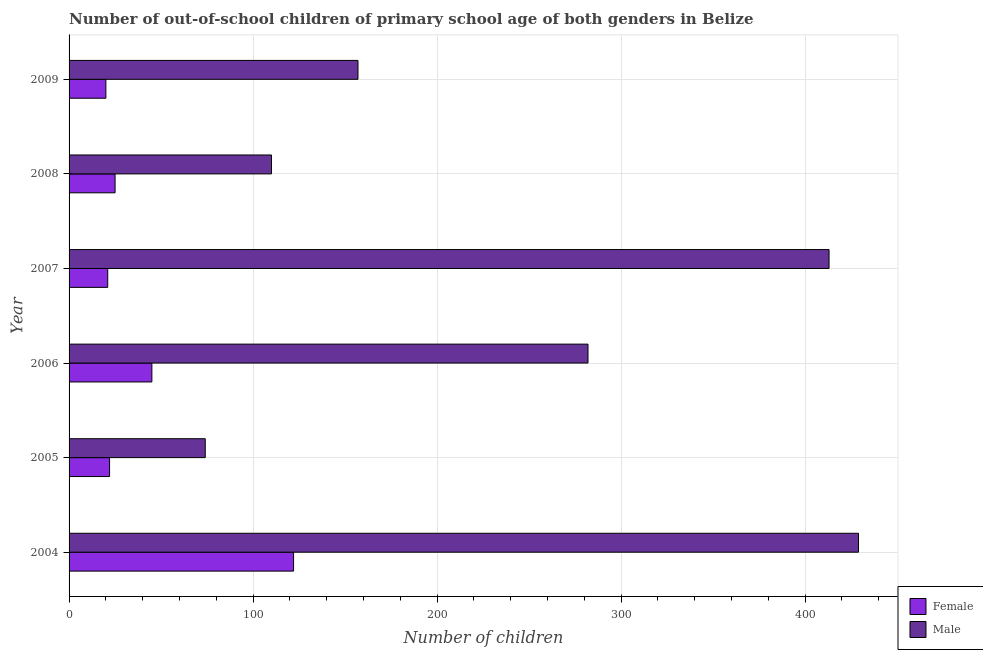How many bars are there on the 3rd tick from the bottom?
Keep it short and to the point. 2. What is the label of the 3rd group of bars from the top?
Provide a succinct answer. 2007. What is the number of male out-of-school students in 2007?
Make the answer very short. 413. Across all years, what is the maximum number of male out-of-school students?
Your response must be concise. 429. Across all years, what is the minimum number of male out-of-school students?
Provide a short and direct response. 74. What is the total number of female out-of-school students in the graph?
Offer a terse response. 255. What is the difference between the number of female out-of-school students in 2004 and that in 2005?
Your response must be concise. 100. What is the difference between the number of male out-of-school students in 2009 and the number of female out-of-school students in 2007?
Your answer should be compact. 136. What is the average number of female out-of-school students per year?
Your answer should be very brief. 42.5. In the year 2005, what is the difference between the number of female out-of-school students and number of male out-of-school students?
Offer a very short reply. -52. What is the ratio of the number of male out-of-school students in 2008 to that in 2009?
Offer a terse response. 0.7. Is the number of male out-of-school students in 2006 less than that in 2009?
Make the answer very short. No. Is the difference between the number of male out-of-school students in 2007 and 2008 greater than the difference between the number of female out-of-school students in 2007 and 2008?
Your answer should be very brief. Yes. What is the difference between the highest and the second highest number of female out-of-school students?
Offer a terse response. 77. What is the difference between the highest and the lowest number of male out-of-school students?
Ensure brevity in your answer.  355. Is the sum of the number of female out-of-school students in 2006 and 2009 greater than the maximum number of male out-of-school students across all years?
Your answer should be compact. No. Are all the bars in the graph horizontal?
Keep it short and to the point. Yes. How many years are there in the graph?
Offer a terse response. 6. Does the graph contain any zero values?
Your answer should be compact. No. Does the graph contain grids?
Give a very brief answer. Yes. How many legend labels are there?
Make the answer very short. 2. What is the title of the graph?
Keep it short and to the point. Number of out-of-school children of primary school age of both genders in Belize. What is the label or title of the X-axis?
Give a very brief answer. Number of children. What is the label or title of the Y-axis?
Provide a succinct answer. Year. What is the Number of children of Female in 2004?
Give a very brief answer. 122. What is the Number of children of Male in 2004?
Offer a terse response. 429. What is the Number of children of Male in 2006?
Offer a very short reply. 282. What is the Number of children in Male in 2007?
Offer a very short reply. 413. What is the Number of children of Female in 2008?
Your response must be concise. 25. What is the Number of children of Male in 2008?
Your answer should be compact. 110. What is the Number of children in Male in 2009?
Offer a very short reply. 157. Across all years, what is the maximum Number of children in Female?
Offer a very short reply. 122. Across all years, what is the maximum Number of children in Male?
Your answer should be very brief. 429. What is the total Number of children in Female in the graph?
Your answer should be compact. 255. What is the total Number of children of Male in the graph?
Make the answer very short. 1465. What is the difference between the Number of children of Female in 2004 and that in 2005?
Offer a very short reply. 100. What is the difference between the Number of children in Male in 2004 and that in 2005?
Provide a short and direct response. 355. What is the difference between the Number of children of Male in 2004 and that in 2006?
Your response must be concise. 147. What is the difference between the Number of children in Female in 2004 and that in 2007?
Provide a short and direct response. 101. What is the difference between the Number of children in Female in 2004 and that in 2008?
Offer a terse response. 97. What is the difference between the Number of children of Male in 2004 and that in 2008?
Offer a very short reply. 319. What is the difference between the Number of children of Female in 2004 and that in 2009?
Offer a very short reply. 102. What is the difference between the Number of children in Male in 2004 and that in 2009?
Provide a succinct answer. 272. What is the difference between the Number of children in Male in 2005 and that in 2006?
Your response must be concise. -208. What is the difference between the Number of children of Female in 2005 and that in 2007?
Your response must be concise. 1. What is the difference between the Number of children of Male in 2005 and that in 2007?
Provide a short and direct response. -339. What is the difference between the Number of children of Female in 2005 and that in 2008?
Give a very brief answer. -3. What is the difference between the Number of children in Male in 2005 and that in 2008?
Offer a very short reply. -36. What is the difference between the Number of children in Male in 2005 and that in 2009?
Your answer should be very brief. -83. What is the difference between the Number of children of Female in 2006 and that in 2007?
Ensure brevity in your answer.  24. What is the difference between the Number of children in Male in 2006 and that in 2007?
Provide a short and direct response. -131. What is the difference between the Number of children in Female in 2006 and that in 2008?
Your answer should be compact. 20. What is the difference between the Number of children of Male in 2006 and that in 2008?
Provide a succinct answer. 172. What is the difference between the Number of children in Female in 2006 and that in 2009?
Your answer should be very brief. 25. What is the difference between the Number of children of Male in 2006 and that in 2009?
Ensure brevity in your answer.  125. What is the difference between the Number of children of Male in 2007 and that in 2008?
Your answer should be compact. 303. What is the difference between the Number of children in Male in 2007 and that in 2009?
Your response must be concise. 256. What is the difference between the Number of children of Female in 2008 and that in 2009?
Provide a succinct answer. 5. What is the difference between the Number of children in Male in 2008 and that in 2009?
Make the answer very short. -47. What is the difference between the Number of children in Female in 2004 and the Number of children in Male in 2006?
Make the answer very short. -160. What is the difference between the Number of children of Female in 2004 and the Number of children of Male in 2007?
Make the answer very short. -291. What is the difference between the Number of children of Female in 2004 and the Number of children of Male in 2009?
Your response must be concise. -35. What is the difference between the Number of children in Female in 2005 and the Number of children in Male in 2006?
Your response must be concise. -260. What is the difference between the Number of children in Female in 2005 and the Number of children in Male in 2007?
Make the answer very short. -391. What is the difference between the Number of children of Female in 2005 and the Number of children of Male in 2008?
Provide a short and direct response. -88. What is the difference between the Number of children of Female in 2005 and the Number of children of Male in 2009?
Offer a terse response. -135. What is the difference between the Number of children of Female in 2006 and the Number of children of Male in 2007?
Make the answer very short. -368. What is the difference between the Number of children in Female in 2006 and the Number of children in Male in 2008?
Make the answer very short. -65. What is the difference between the Number of children of Female in 2006 and the Number of children of Male in 2009?
Your answer should be compact. -112. What is the difference between the Number of children of Female in 2007 and the Number of children of Male in 2008?
Offer a terse response. -89. What is the difference between the Number of children of Female in 2007 and the Number of children of Male in 2009?
Make the answer very short. -136. What is the difference between the Number of children in Female in 2008 and the Number of children in Male in 2009?
Provide a short and direct response. -132. What is the average Number of children in Female per year?
Provide a succinct answer. 42.5. What is the average Number of children in Male per year?
Your response must be concise. 244.17. In the year 2004, what is the difference between the Number of children in Female and Number of children in Male?
Keep it short and to the point. -307. In the year 2005, what is the difference between the Number of children in Female and Number of children in Male?
Give a very brief answer. -52. In the year 2006, what is the difference between the Number of children in Female and Number of children in Male?
Make the answer very short. -237. In the year 2007, what is the difference between the Number of children in Female and Number of children in Male?
Offer a terse response. -392. In the year 2008, what is the difference between the Number of children in Female and Number of children in Male?
Ensure brevity in your answer.  -85. In the year 2009, what is the difference between the Number of children of Female and Number of children of Male?
Your answer should be very brief. -137. What is the ratio of the Number of children of Female in 2004 to that in 2005?
Your answer should be compact. 5.55. What is the ratio of the Number of children of Male in 2004 to that in 2005?
Provide a short and direct response. 5.8. What is the ratio of the Number of children of Female in 2004 to that in 2006?
Offer a very short reply. 2.71. What is the ratio of the Number of children of Male in 2004 to that in 2006?
Your answer should be compact. 1.52. What is the ratio of the Number of children in Female in 2004 to that in 2007?
Offer a terse response. 5.81. What is the ratio of the Number of children of Male in 2004 to that in 2007?
Offer a very short reply. 1.04. What is the ratio of the Number of children in Female in 2004 to that in 2008?
Offer a very short reply. 4.88. What is the ratio of the Number of children in Male in 2004 to that in 2008?
Your answer should be compact. 3.9. What is the ratio of the Number of children of Female in 2004 to that in 2009?
Your response must be concise. 6.1. What is the ratio of the Number of children in Male in 2004 to that in 2009?
Provide a short and direct response. 2.73. What is the ratio of the Number of children in Female in 2005 to that in 2006?
Provide a succinct answer. 0.49. What is the ratio of the Number of children of Male in 2005 to that in 2006?
Keep it short and to the point. 0.26. What is the ratio of the Number of children in Female in 2005 to that in 2007?
Keep it short and to the point. 1.05. What is the ratio of the Number of children in Male in 2005 to that in 2007?
Your answer should be very brief. 0.18. What is the ratio of the Number of children in Female in 2005 to that in 2008?
Ensure brevity in your answer.  0.88. What is the ratio of the Number of children in Male in 2005 to that in 2008?
Your answer should be very brief. 0.67. What is the ratio of the Number of children in Female in 2005 to that in 2009?
Your response must be concise. 1.1. What is the ratio of the Number of children in Male in 2005 to that in 2009?
Your answer should be very brief. 0.47. What is the ratio of the Number of children in Female in 2006 to that in 2007?
Provide a short and direct response. 2.14. What is the ratio of the Number of children of Male in 2006 to that in 2007?
Your response must be concise. 0.68. What is the ratio of the Number of children in Female in 2006 to that in 2008?
Offer a terse response. 1.8. What is the ratio of the Number of children of Male in 2006 to that in 2008?
Provide a succinct answer. 2.56. What is the ratio of the Number of children of Female in 2006 to that in 2009?
Give a very brief answer. 2.25. What is the ratio of the Number of children in Male in 2006 to that in 2009?
Ensure brevity in your answer.  1.8. What is the ratio of the Number of children in Female in 2007 to that in 2008?
Your response must be concise. 0.84. What is the ratio of the Number of children in Male in 2007 to that in 2008?
Ensure brevity in your answer.  3.75. What is the ratio of the Number of children of Male in 2007 to that in 2009?
Offer a very short reply. 2.63. What is the ratio of the Number of children in Male in 2008 to that in 2009?
Ensure brevity in your answer.  0.7. What is the difference between the highest and the second highest Number of children in Female?
Make the answer very short. 77. What is the difference between the highest and the second highest Number of children in Male?
Your answer should be very brief. 16. What is the difference between the highest and the lowest Number of children of Female?
Provide a succinct answer. 102. What is the difference between the highest and the lowest Number of children of Male?
Offer a very short reply. 355. 